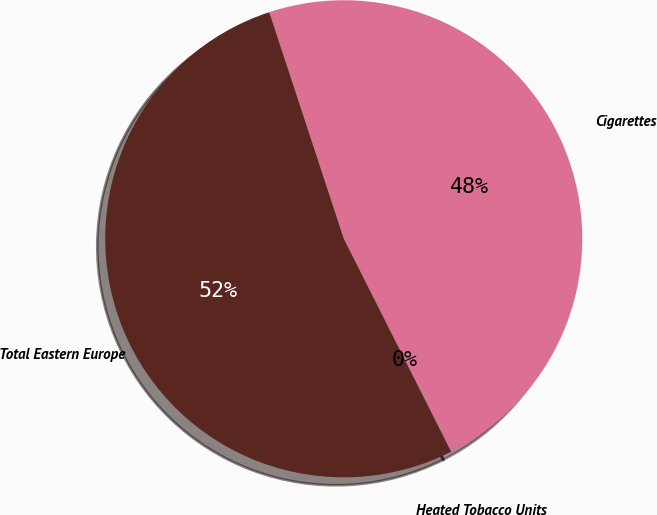<chart> <loc_0><loc_0><loc_500><loc_500><pie_chart><fcel>Cigarettes<fcel>Heated Tobacco Units<fcel>Total Eastern Europe<nl><fcel>47.61%<fcel>0.02%<fcel>52.37%<nl></chart> 